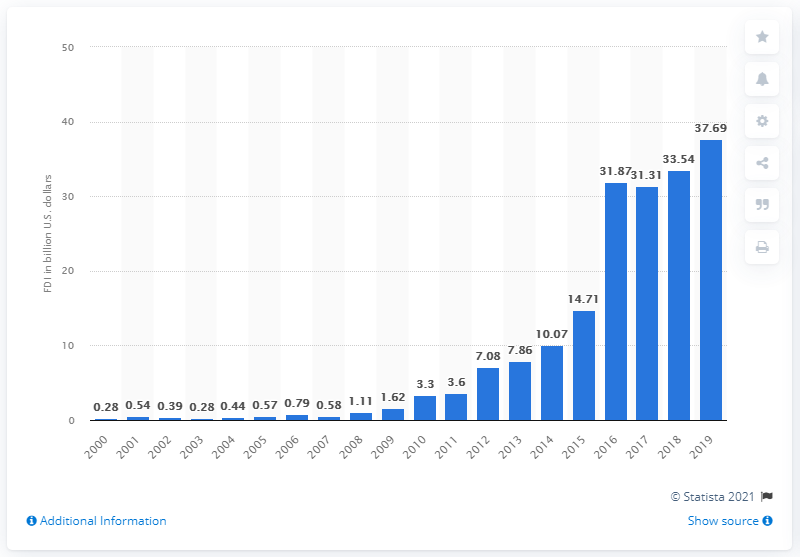Give some essential details in this illustration. In 2019, Chinese companies invested a significant amount of money in the United States, totaling 37.69 billion U.S. dollars. 